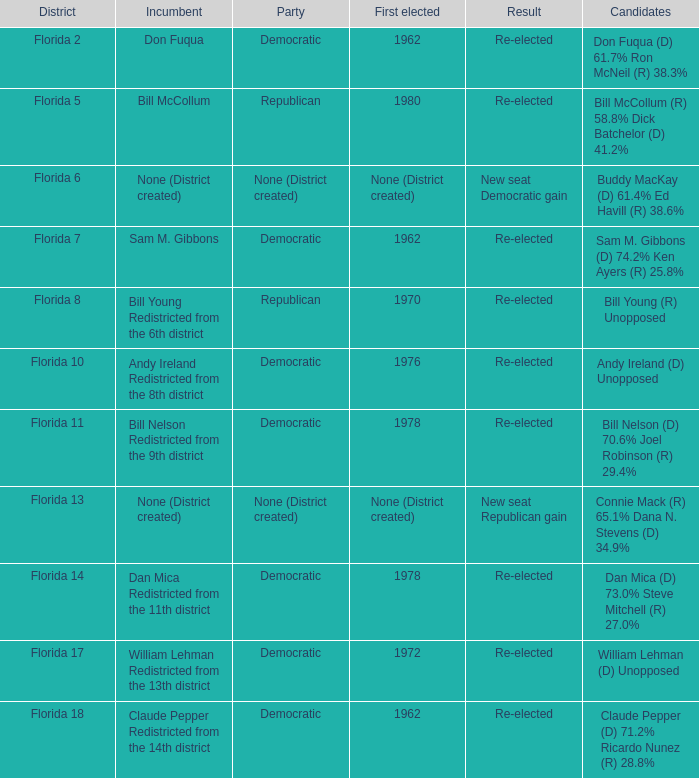What's the consequence with the district being florida 7? Re-elected. 